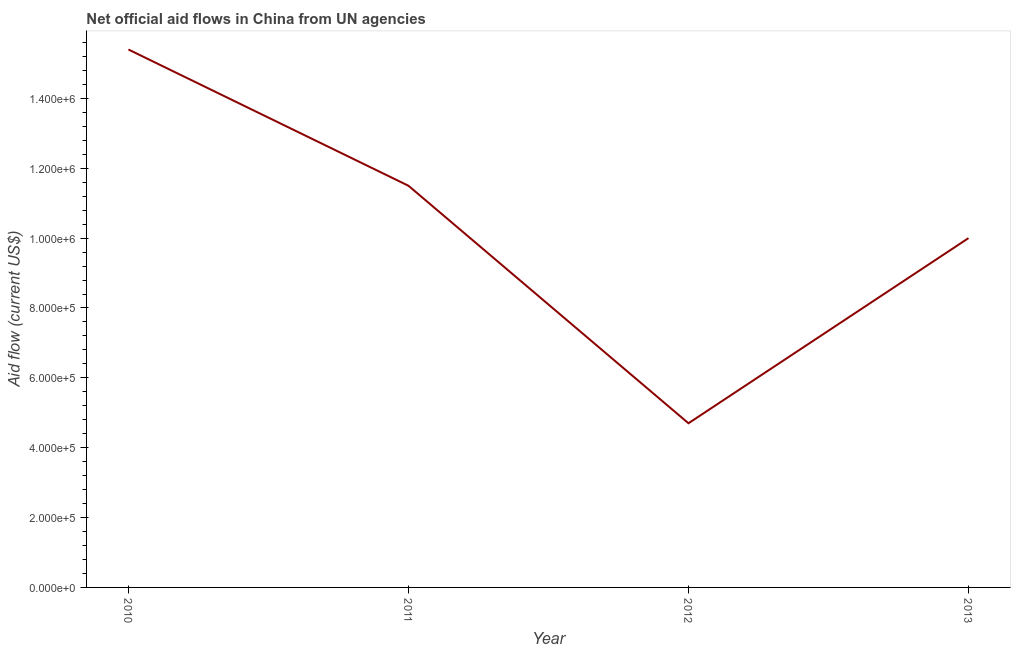What is the net official flows from un agencies in 2011?
Keep it short and to the point. 1.15e+06. Across all years, what is the maximum net official flows from un agencies?
Your answer should be very brief. 1.54e+06. Across all years, what is the minimum net official flows from un agencies?
Offer a terse response. 4.70e+05. In which year was the net official flows from un agencies maximum?
Provide a succinct answer. 2010. In which year was the net official flows from un agencies minimum?
Your answer should be compact. 2012. What is the sum of the net official flows from un agencies?
Your answer should be compact. 4.16e+06. What is the difference between the net official flows from un agencies in 2010 and 2011?
Provide a succinct answer. 3.90e+05. What is the average net official flows from un agencies per year?
Your answer should be very brief. 1.04e+06. What is the median net official flows from un agencies?
Give a very brief answer. 1.08e+06. In how many years, is the net official flows from un agencies greater than 1320000 US$?
Offer a terse response. 1. Do a majority of the years between 2013 and 2012 (inclusive) have net official flows from un agencies greater than 480000 US$?
Provide a succinct answer. No. What is the ratio of the net official flows from un agencies in 2010 to that in 2012?
Provide a succinct answer. 3.28. What is the difference between the highest and the lowest net official flows from un agencies?
Ensure brevity in your answer.  1.07e+06. In how many years, is the net official flows from un agencies greater than the average net official flows from un agencies taken over all years?
Provide a short and direct response. 2. How many lines are there?
Provide a succinct answer. 1. What is the difference between two consecutive major ticks on the Y-axis?
Offer a very short reply. 2.00e+05. Are the values on the major ticks of Y-axis written in scientific E-notation?
Make the answer very short. Yes. What is the title of the graph?
Ensure brevity in your answer.  Net official aid flows in China from UN agencies. What is the Aid flow (current US$) of 2010?
Keep it short and to the point. 1.54e+06. What is the Aid flow (current US$) in 2011?
Make the answer very short. 1.15e+06. What is the Aid flow (current US$) of 2013?
Make the answer very short. 1.00e+06. What is the difference between the Aid flow (current US$) in 2010 and 2012?
Your answer should be compact. 1.07e+06. What is the difference between the Aid flow (current US$) in 2010 and 2013?
Make the answer very short. 5.40e+05. What is the difference between the Aid flow (current US$) in 2011 and 2012?
Your answer should be very brief. 6.80e+05. What is the difference between the Aid flow (current US$) in 2011 and 2013?
Make the answer very short. 1.50e+05. What is the difference between the Aid flow (current US$) in 2012 and 2013?
Your response must be concise. -5.30e+05. What is the ratio of the Aid flow (current US$) in 2010 to that in 2011?
Your response must be concise. 1.34. What is the ratio of the Aid flow (current US$) in 2010 to that in 2012?
Your answer should be very brief. 3.28. What is the ratio of the Aid flow (current US$) in 2010 to that in 2013?
Offer a terse response. 1.54. What is the ratio of the Aid flow (current US$) in 2011 to that in 2012?
Give a very brief answer. 2.45. What is the ratio of the Aid flow (current US$) in 2011 to that in 2013?
Ensure brevity in your answer.  1.15. What is the ratio of the Aid flow (current US$) in 2012 to that in 2013?
Offer a very short reply. 0.47. 